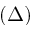Convert formula to latex. <formula><loc_0><loc_0><loc_500><loc_500>( \Delta )</formula> 